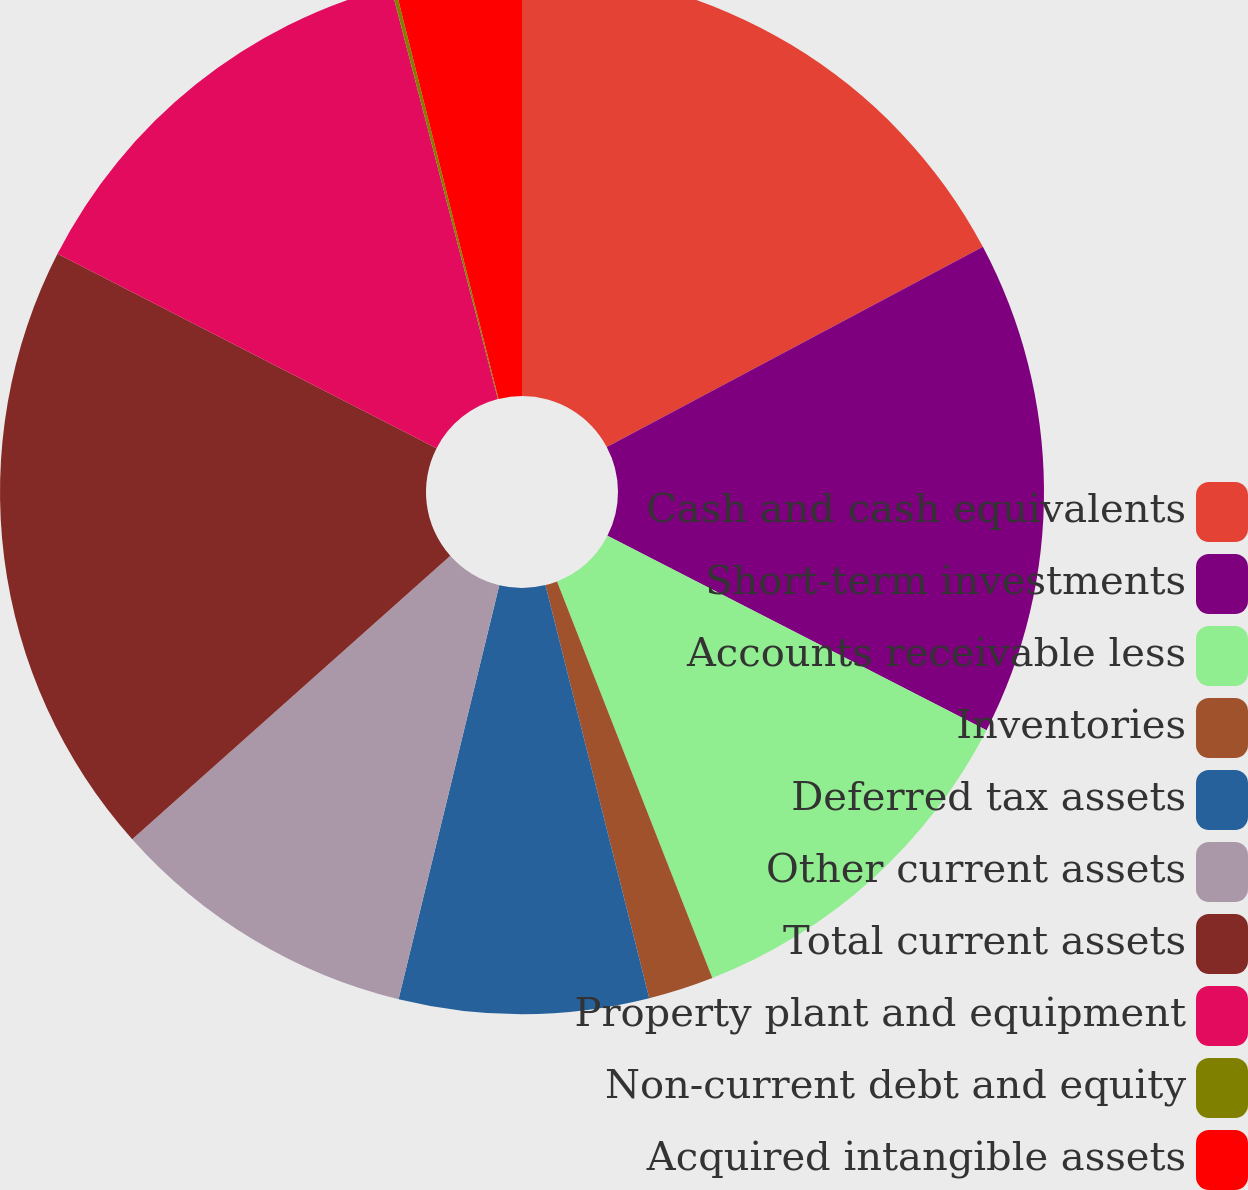Convert chart. <chart><loc_0><loc_0><loc_500><loc_500><pie_chart><fcel>Cash and cash equivalents<fcel>Short-term investments<fcel>Accounts receivable less<fcel>Inventories<fcel>Deferred tax assets<fcel>Other current assets<fcel>Total current assets<fcel>Property plant and equipment<fcel>Non-current debt and equity<fcel>Acquired intangible assets<nl><fcel>17.22%<fcel>15.32%<fcel>11.52%<fcel>2.02%<fcel>7.72%<fcel>9.62%<fcel>19.12%<fcel>13.42%<fcel>0.12%<fcel>3.92%<nl></chart> 